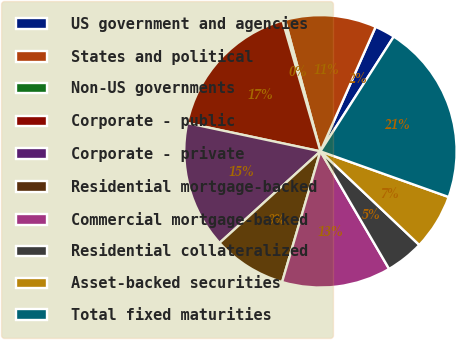<chart> <loc_0><loc_0><loc_500><loc_500><pie_chart><fcel>US government and agencies<fcel>States and political<fcel>Non-US governments<fcel>Corporate - public<fcel>Corporate - private<fcel>Residential mortgage-backed<fcel>Commercial mortgage-backed<fcel>Residential collateralized<fcel>Asset-backed securities<fcel>Total fixed maturities<nl><fcel>2.41%<fcel>10.84%<fcel>0.3%<fcel>17.17%<fcel>15.06%<fcel>8.73%<fcel>12.95%<fcel>4.52%<fcel>6.62%<fcel>21.39%<nl></chart> 